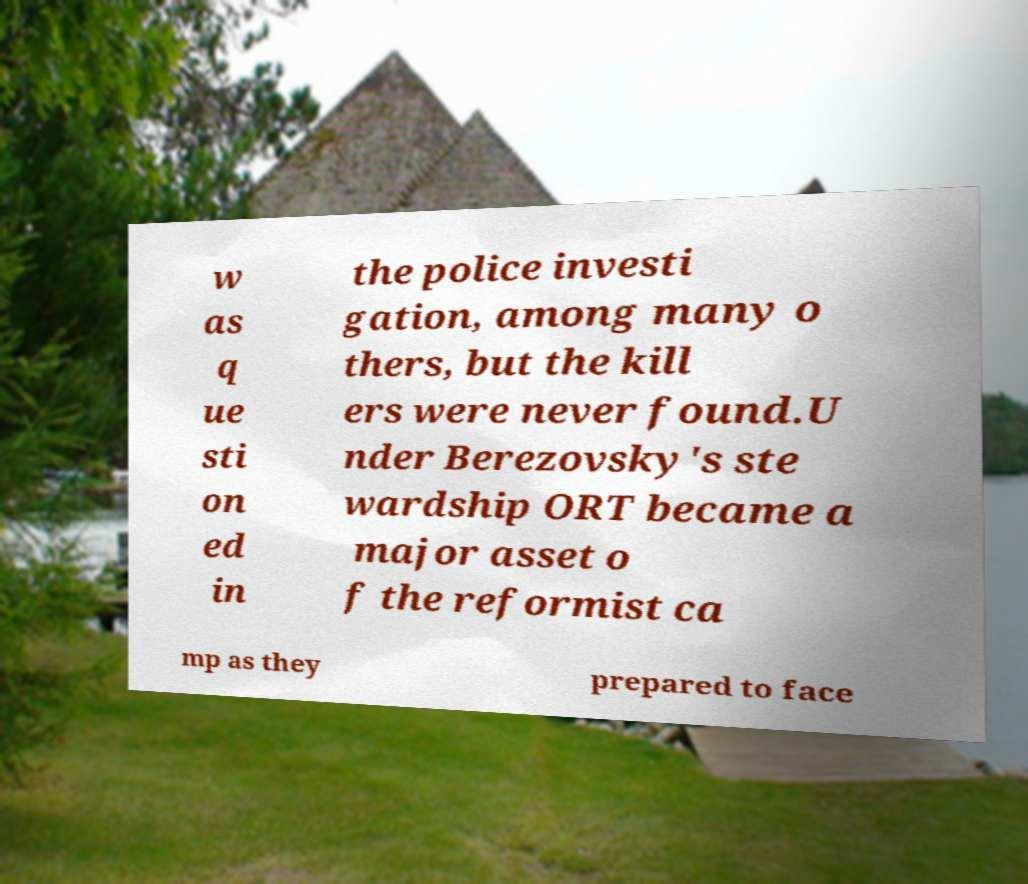Please read and relay the text visible in this image. What does it say? w as q ue sti on ed in the police investi gation, among many o thers, but the kill ers were never found.U nder Berezovsky's ste wardship ORT became a major asset o f the reformist ca mp as they prepared to face 